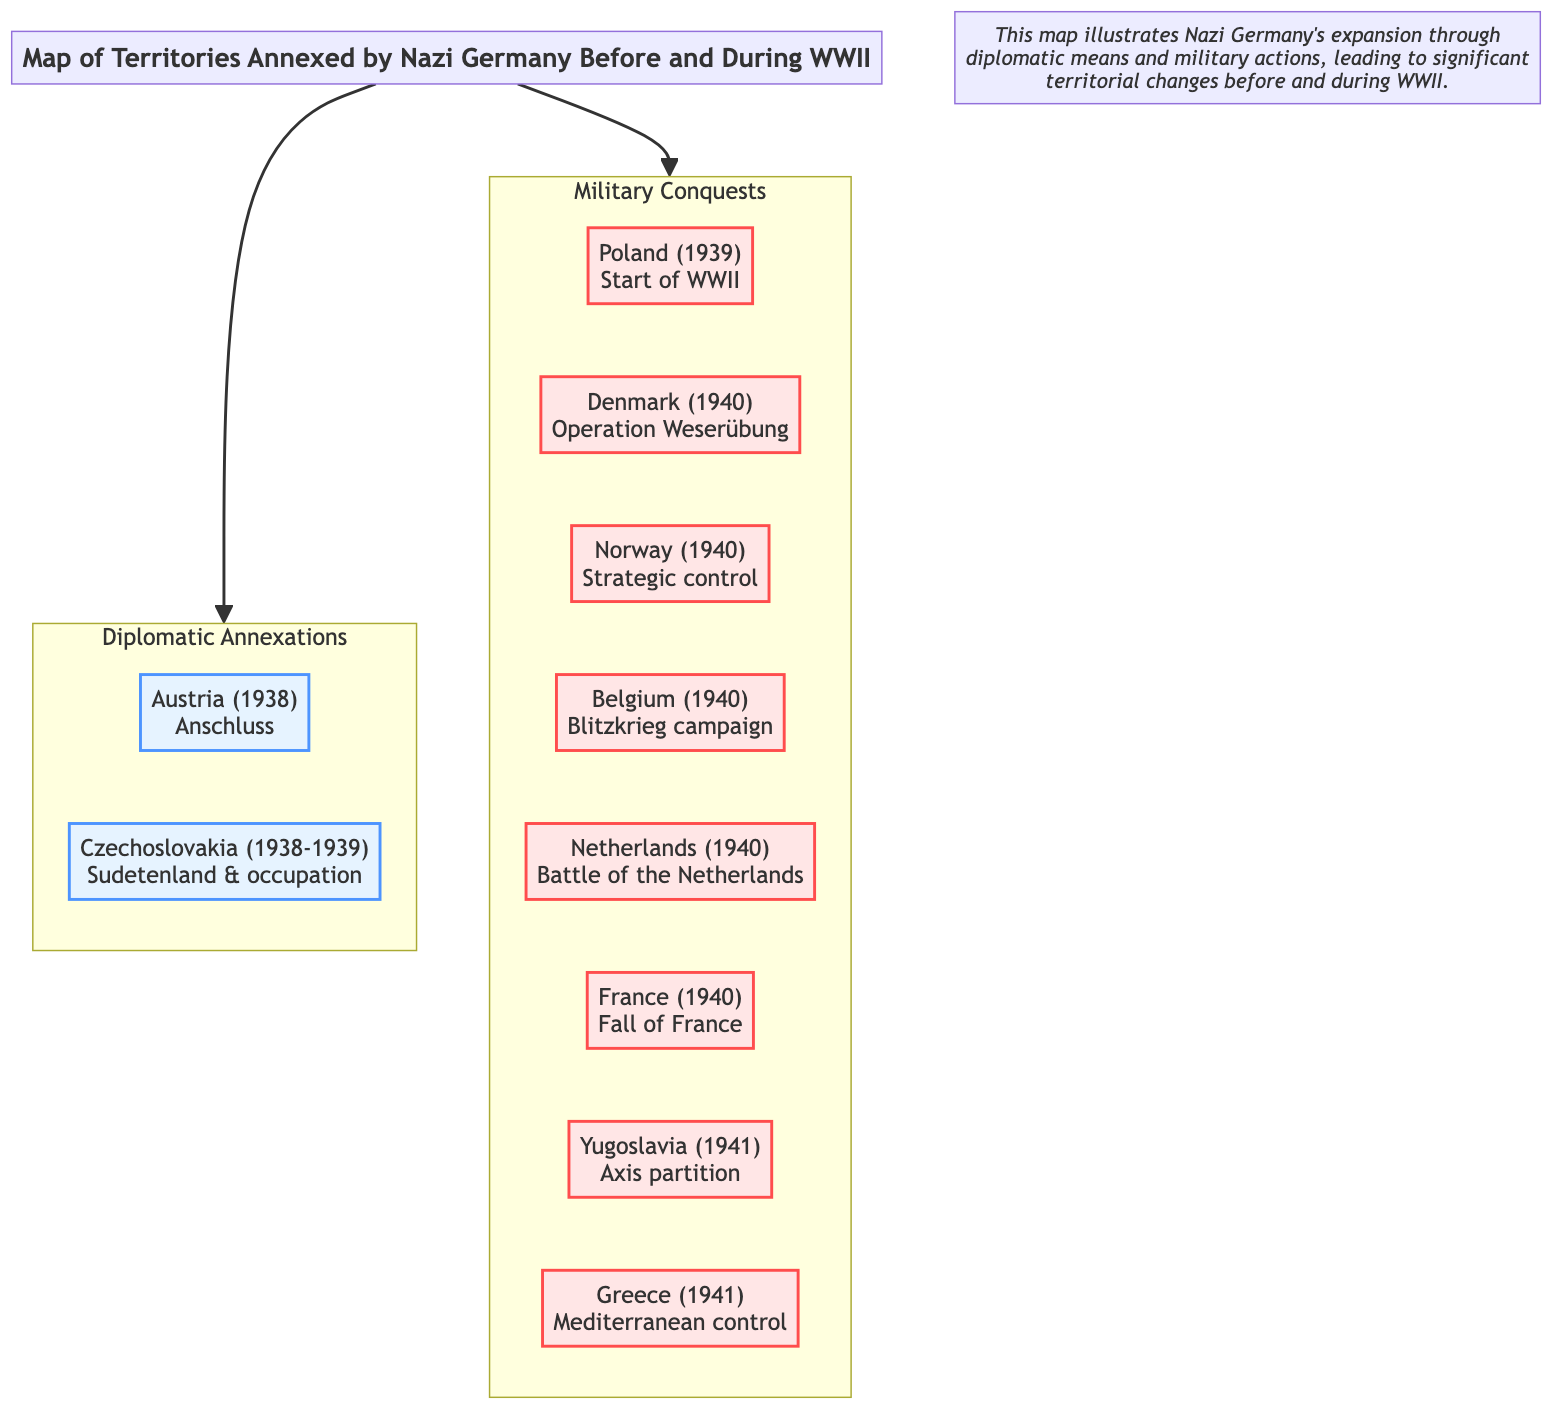What territories were annexed diplomatically by Nazi Germany? The diagram indicates the territories annexed diplomatically by Nazi Germany are Austria and Czechoslovakia. Both are highlighted under the "Diplomatic Annexations" section.
Answer: Austria, Czechoslovakia Which country was the first military conquest in WWII by Nazi Germany? According to the diagram, Poland was the first military conquest, as indicated in the "Military Conquests" section and marked by the label "Start of WWII."
Answer: Poland How many countries are listed under military conquests? The diagram displays a total of seven countries under the "Military Conquests" section: Poland, Denmark, Norway, Belgium, Netherlands, France, Yugoslavia, and Greece, which can be counted for a total.
Answer: 7 What operation is associated with the military conquest of Denmark? The diagram specifies "Operation Weserübung" as the military campaign tied to the conquest of Denmark, which is detailed in the corresponding node.
Answer: Operation Weserübung Which country was annexed through diplomatic means in 1938? The diagram indicates that Austria was annexed through diplomatic means in 1938, as labeled in the "Diplomatic Annexations" section.
Answer: Austria What color represents military conquests in the diagram? The diagram shows that military conquests are represented in a light red color (#FFE6E6), differentiating them visually from diplomatic annexations.
Answer: Light red Which two events led to the occupation of Czechoslovakia? The diagram lists Czechoslovakia as being annexed in two stages: the "Sudetenland" acquisition and subsequent "occupation." Thus, both events are tied to its annexation.
Answer: Sudetenland & occupation Which two regions illustrate the territorial expansion before WWII according to the diagram? The diagram identifies Austria and Czechoslovakia as the two regions that illustrate the territorial expansion by Nazi Germany before WWII, located under "Diplomatic Annexations."
Answer: Austria, Czechoslovakia 